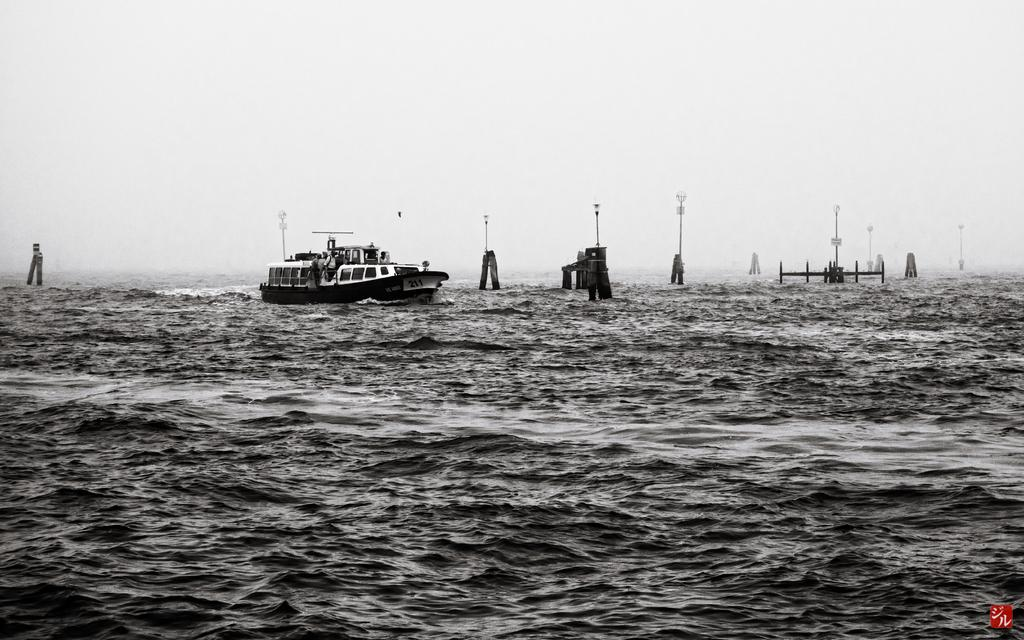What is the main subject of the image? The main subject of the image is a ship. Where is the ship located? The ship is on the sea. What structures can be seen in the image besides the ship? There are pillars and poles in the image. What part of the natural environment is visible in the image? The sky and water are visible in the image. What type of trousers can be seen hanging from the poles in the image? There are no trousers present in the image; it only features a ship, pillars, and poles. What level of poison is present in the water in the image? There is no mention of poison in the image, and the water appears to be a natural part of the sea. 